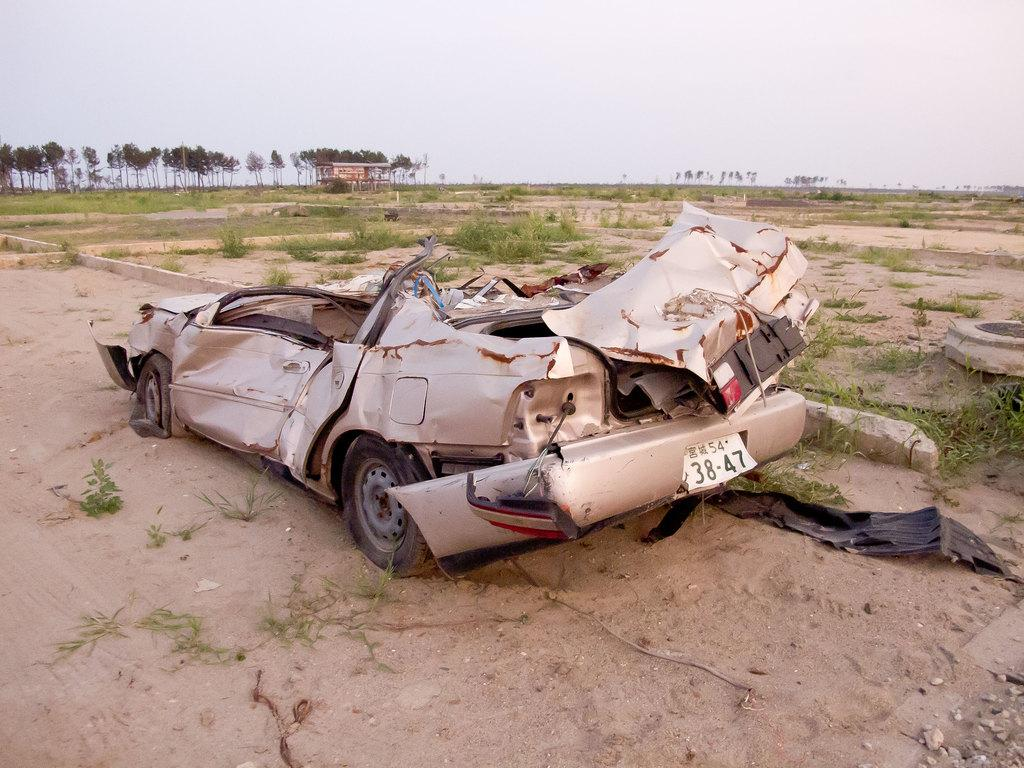What is the main subject in the center of the image? There is a damaged vehicle in the center of the image. What can be seen in the background of the image? There are plants, a shed, and trees in the background of the image. What is visible at the bottom of the image? The ground is visible at the bottom of the image. How many pencils are lying on the ground next to the damaged vehicle? There are no pencils visible in the image; the focus is on the damaged vehicle and the background elements. 